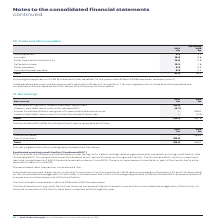According to Auto Trader's financial document, When are trade payables paid? within 30 days of recognition. The document states: "Trade payables are unsecured and are usually paid within 30 days of recognition. The carrying amounts of trade and other payables are considered to be..." Also, Why are trade payables in 2018 restated in the table? Following the application of IFRS 16. The document states: "Following the application of IFRS 16, trade and other payables for the year ended 31 March 2018 have been restated (note 2)...." Also, In which years were the components in trade and other payables calculated in? The document shows two values: 2019 and 2018. From the document: "Group plc Annual Report and Financial Statements 2019 (Restated) 2018 £m..." Additionally, In which year were Trade payables larger? According to the financial document, 2019. The relevant text states: "Group plc Annual Report and Financial Statements 2019..." Also, can you calculate: What was the change in trade payables in 2019 from 2018? Based on the calculation: 4.3-3.7, the result is 0.6 (in millions). This is based on the information: "Trade payables 4.3 3.7 Trade payables 4.3 3.7..." The key data points involved are: 3.7, 4.3. Also, can you calculate: What was the percentage change in trade payables in 2019 from 2018? To answer this question, I need to perform calculations using the financial data. The calculation is: (4.3-3.7)/3.7, which equals 16.22 (percentage). This is based on the information: "Trade payables 4.3 3.7 Trade payables 4.3 3.7..." The key data points involved are: 3.7, 4.3. 